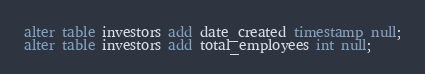Convert code to text. <code><loc_0><loc_0><loc_500><loc_500><_SQL_>alter table investors add date_created timestamp null;
alter table investors add total_employees int null;
</code> 